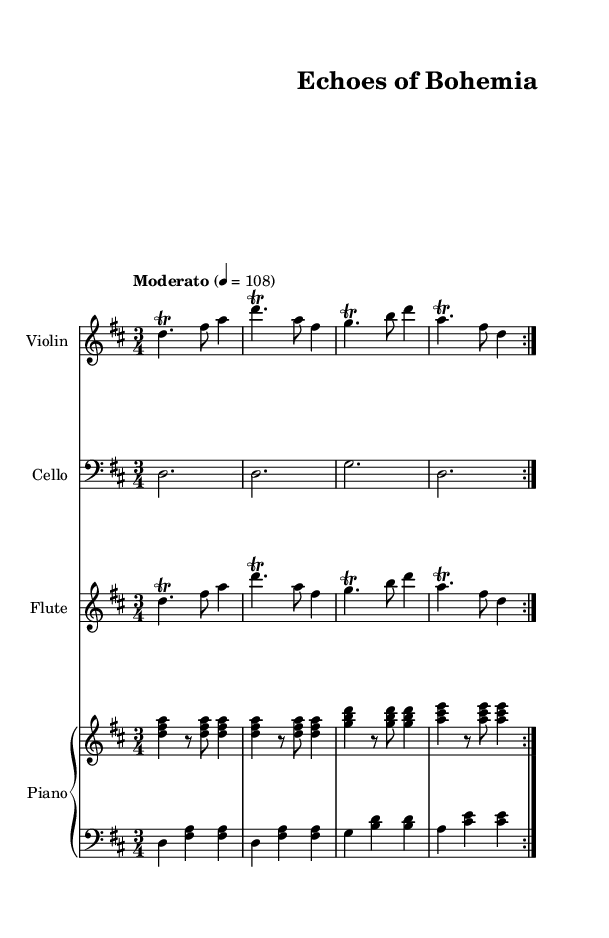What is the key signature of this music? The key signature is D major, which has two sharps (F sharp and C sharp). You can identify it by looking at the key signature notation at the beginning of the piece.
Answer: D major What is the time signature of this music? The time signature is 3/4, indicated at the beginning of the music. This means there are three beats in each measure, with a quarter note receiving one beat.
Answer: 3/4 What is the tempo marking? The tempo marking is "Moderato," which is indicated above the first measure. It signifies a moderate speed of the music.
Answer: Moderato How many volta repetitions are indicated in the music? The music indicates two volta repetitions, shown by the "repeat volta 2" instruction. This means that the section should be played twice.
Answer: 2 What instruments are featured in this piece? The piece features violin, cello, flute, and piano. The instruments are specified at the beginning of each staff in the score.
Answer: Violin, cello, flute, piano What is the main motif used in the violin part? The main motif in the violin part consists of a repeated melodic figure that includes trills and a specific note pattern (D, F sharp, A). This is evident from the repeated measures.
Answer: Trills How does the lower piano staff relate to the upper piano staff? The lower piano staff plays chordal harmonies (D and A major chords) that complement the melodic line in the upper staff, which plays arpeggiated figures that harmonize with it. This demonstrates a typical accompaniment style in soundtracks.
Answer: Harmonic support 